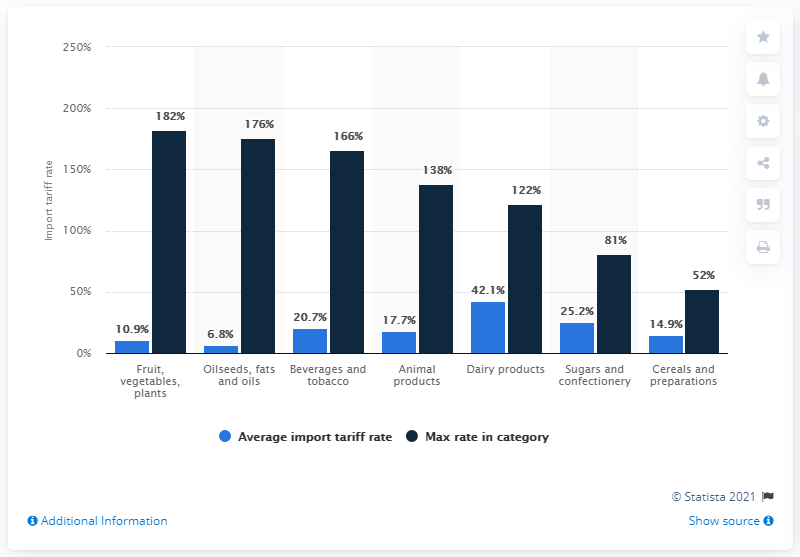List a handful of essential elements in this visual. The maximum potential rate of the EU Common Customs Tariff is 122... 